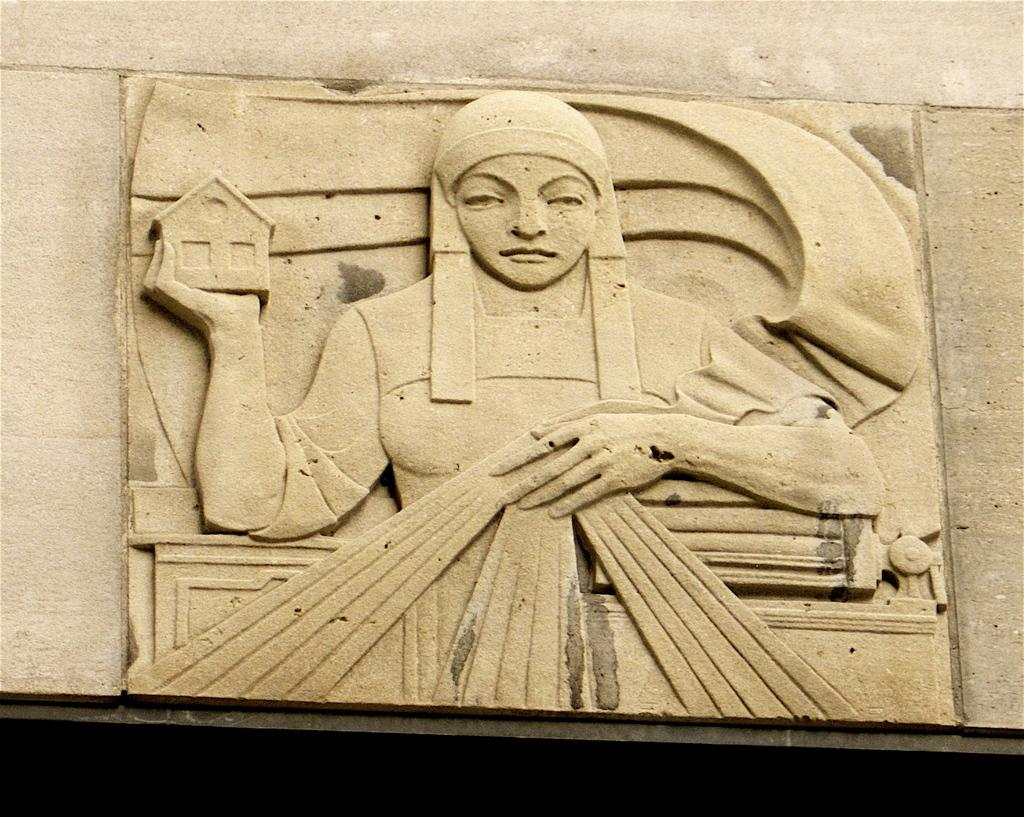What is the main subject in the image? There is a stone carving in the image. Can you describe the setting of the stone carving? The stone carving is on a platform. What type of wealth is depicted in the stone carving? There is no depiction of wealth in the stone carving; it is a carving made of stone. Can you touch the stone carving in the image? The image is a two-dimensional representation, so you cannot touch the stone carving in the image. 